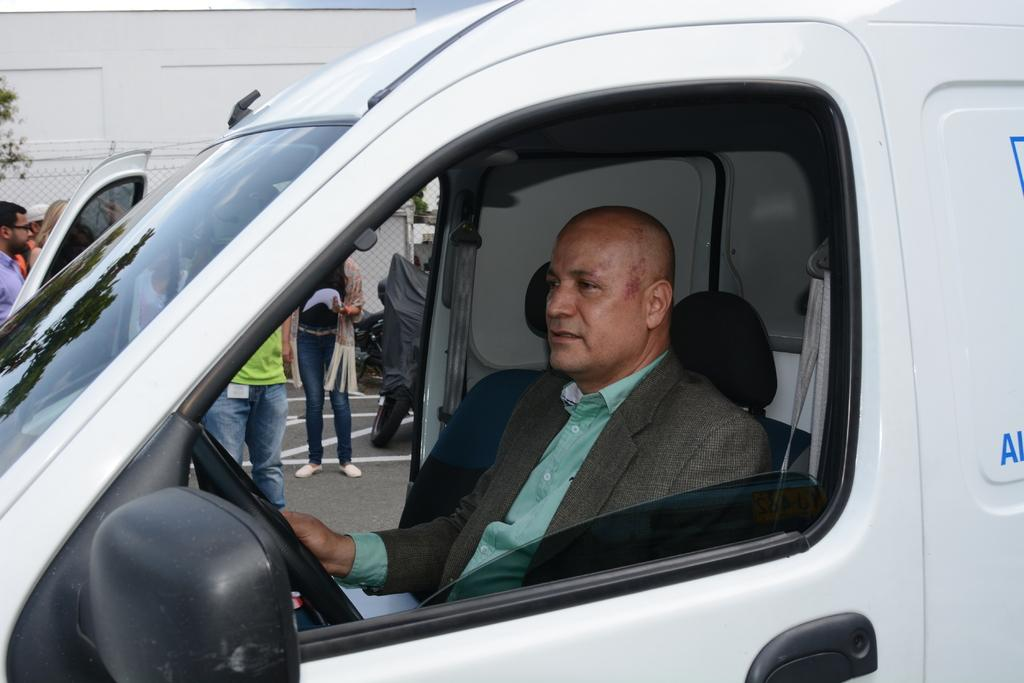What is the man in the image doing? The man is sitting in a vehicle. What can be seen in the background of the image? There are people standing on a road and fencing visible in the background. What type of structure is in the background? There is a building in the background. What book is the man reading in the image? There is no book visible in the image, and the man is not shown reading. 